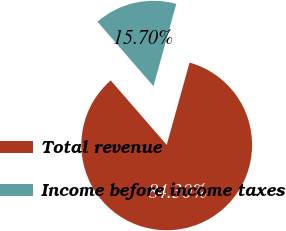Convert chart. <chart><loc_0><loc_0><loc_500><loc_500><pie_chart><fcel>Total revenue<fcel>Income before income taxes<nl><fcel>84.3%<fcel>15.7%<nl></chart> 